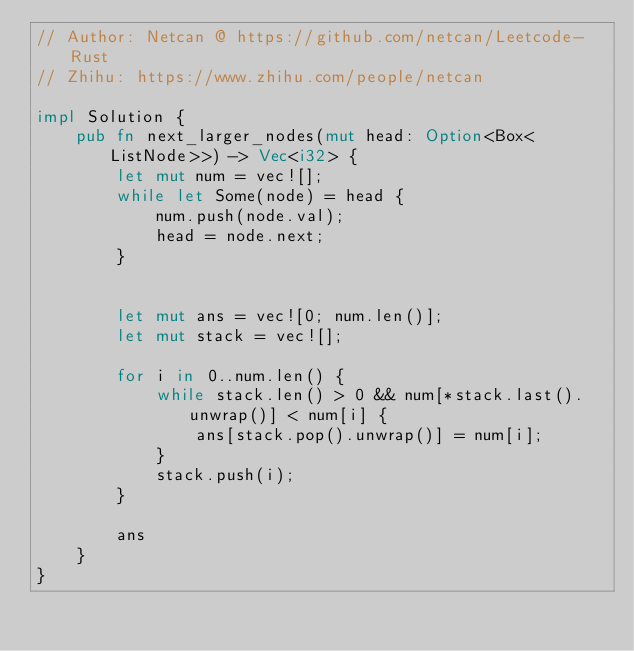<code> <loc_0><loc_0><loc_500><loc_500><_Rust_>// Author: Netcan @ https://github.com/netcan/Leetcode-Rust
// Zhihu: https://www.zhihu.com/people/netcan

impl Solution {
    pub fn next_larger_nodes(mut head: Option<Box<ListNode>>) -> Vec<i32> {
        let mut num = vec![];
        while let Some(node) = head {
            num.push(node.val);
            head = node.next;
        }


        let mut ans = vec![0; num.len()];
        let mut stack = vec![];

        for i in 0..num.len() {
            while stack.len() > 0 && num[*stack.last().unwrap()] < num[i] {
                ans[stack.pop().unwrap()] = num[i];
            }
            stack.push(i);
        }

        ans
    }
}
</code> 